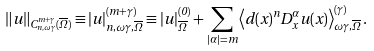<formula> <loc_0><loc_0><loc_500><loc_500>\left \| u \right \| _ { C _ { n , \omega \gamma } ^ { m + \gamma } ( \overline { \Omega } ) } \equiv | u | _ { n , \omega \gamma , \overline { \Omega } } ^ { ( m + \gamma ) } \equiv | u | _ { \overline { \Omega } } ^ { ( 0 ) } + \sum _ { | \alpha | = m } \left \langle d ( x ) ^ { n } D _ { x } ^ { \alpha } u ( x ) \right \rangle _ { \omega \gamma , \overline { \Omega } } ^ { ( \gamma ) } .</formula> 